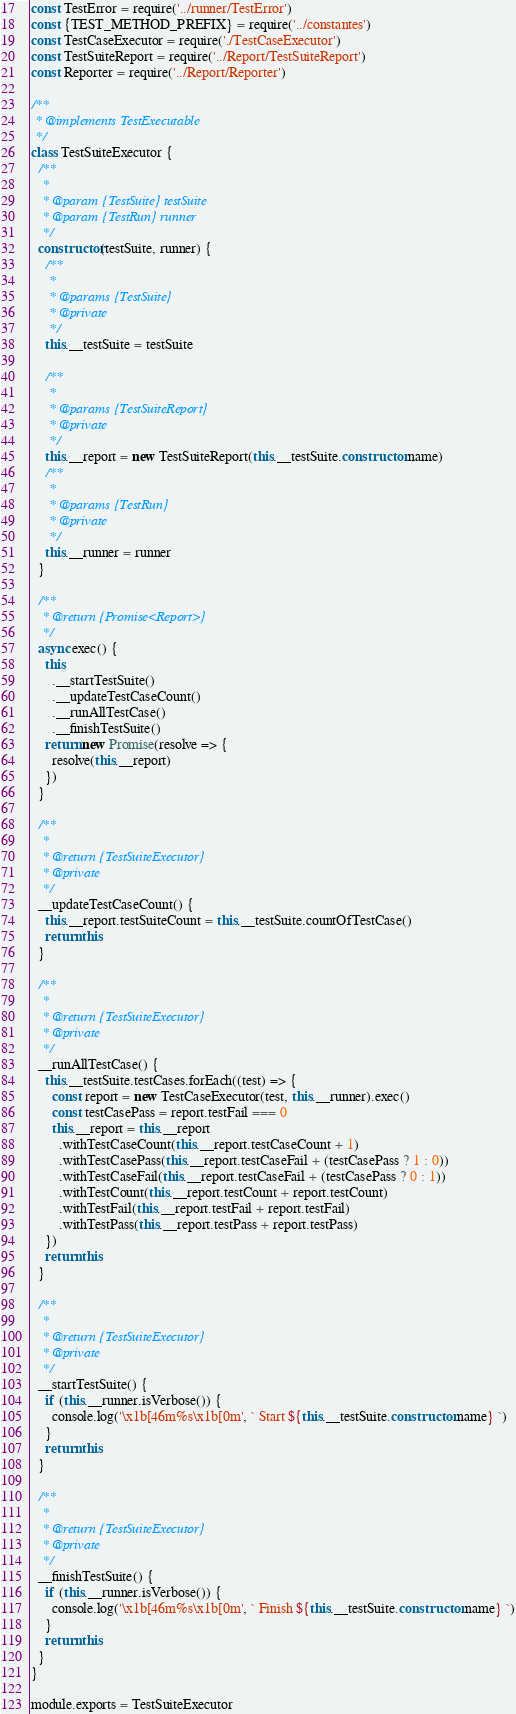Convert code to text. <code><loc_0><loc_0><loc_500><loc_500><_JavaScript_>const TestError = require('../runner/TestError')
const {TEST_METHOD_PREFIX} = require('../constantes')
const TestCaseExecutor = require('./TestCaseExecutor')
const TestSuiteReport = require('../Report/TestSuiteReport')
const Reporter = require('../Report/Reporter')

/**
 * @implements TestExecutable
 */
class TestSuiteExecutor {
  /**
   *
   * @param {TestSuite} testSuite
   * @param {TestRun} runner
   */
  constructor(testSuite, runner) {
    /**
     *
     * @params {TestSuite}
     * @private
     */
    this.__testSuite = testSuite

    /**
     *
     * @params {TestSuiteReport}
     * @private
     */
    this.__report = new TestSuiteReport(this.__testSuite.constructor.name)
    /**
     *
     * @params {TestRun}
     * @private
     */
    this.__runner = runner
  }

  /**
   * @return {Promise<Report>}
   */
  async exec() {
    this
      .__startTestSuite()
      .__updateTestCaseCount()
      .__runAllTestCase()
      .__finishTestSuite()
    return new Promise(resolve => {
      resolve(this.__report)
    })
  }

  /**
   *
   * @return {TestSuiteExecutor}
   * @private
   */
  __updateTestCaseCount() {
    this.__report.testSuiteCount = this.__testSuite.countOfTestCase()
    return this
  }

  /**
   *
   * @return {TestSuiteExecutor}
   * @private
   */
  __runAllTestCase() {
    this.__testSuite.testCases.forEach((test) => {
      const report = new TestCaseExecutor(test, this.__runner).exec()
      const testCasePass = report.testFail === 0
      this.__report = this.__report
        .withTestCaseCount(this.__report.testCaseCount + 1)
        .withTestCasePass(this.__report.testCaseFail + (testCasePass ? 1 : 0))
        .withTestCaseFail(this.__report.testCaseFail + (testCasePass ? 0 : 1))
        .withTestCount(this.__report.testCount + report.testCount)
        .withTestFail(this.__report.testFail + report.testFail)
        .withTestPass(this.__report.testPass + report.testPass)
    })
    return this
  }

  /**
   *
   * @return {TestSuiteExecutor}
   * @private
   */
  __startTestSuite() {
    if (this.__runner.isVerbose()) {
      console.log('\x1b[46m%s\x1b[0m', ` Start ${this.__testSuite.constructor.name} `)
    }
    return this
  }

  /**
   *
   * @return {TestSuiteExecutor}
   * @private
   */
  __finishTestSuite() {
    if (this.__runner.isVerbose()) {
      console.log('\x1b[46m%s\x1b[0m', ` Finish ${this.__testSuite.constructor.name} `)
    }
    return this
  }
}

module.exports = TestSuiteExecutor
</code> 